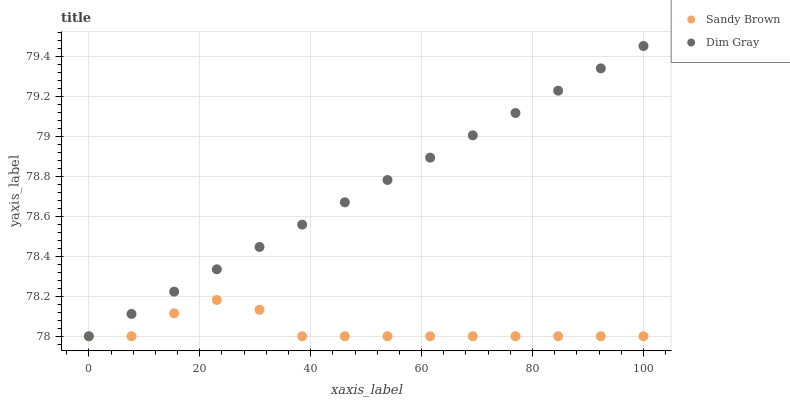Does Sandy Brown have the minimum area under the curve?
Answer yes or no. Yes. Does Dim Gray have the maximum area under the curve?
Answer yes or no. Yes. Does Sandy Brown have the maximum area under the curve?
Answer yes or no. No. Is Dim Gray the smoothest?
Answer yes or no. Yes. Is Sandy Brown the roughest?
Answer yes or no. Yes. Is Sandy Brown the smoothest?
Answer yes or no. No. Does Dim Gray have the lowest value?
Answer yes or no. Yes. Does Dim Gray have the highest value?
Answer yes or no. Yes. Does Sandy Brown have the highest value?
Answer yes or no. No. Does Dim Gray intersect Sandy Brown?
Answer yes or no. Yes. Is Dim Gray less than Sandy Brown?
Answer yes or no. No. Is Dim Gray greater than Sandy Brown?
Answer yes or no. No. 